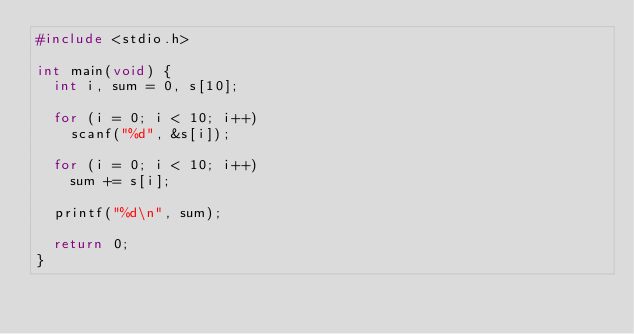Convert code to text. <code><loc_0><loc_0><loc_500><loc_500><_C_>#include <stdio.h>

int main(void) {
  int i, sum = 0, s[10];

  for (i = 0; i < 10; i++)
    scanf("%d", &s[i]);

  for (i = 0; i < 10; i++)
    sum += s[i];

  printf("%d\n", sum);

  return 0;
}</code> 